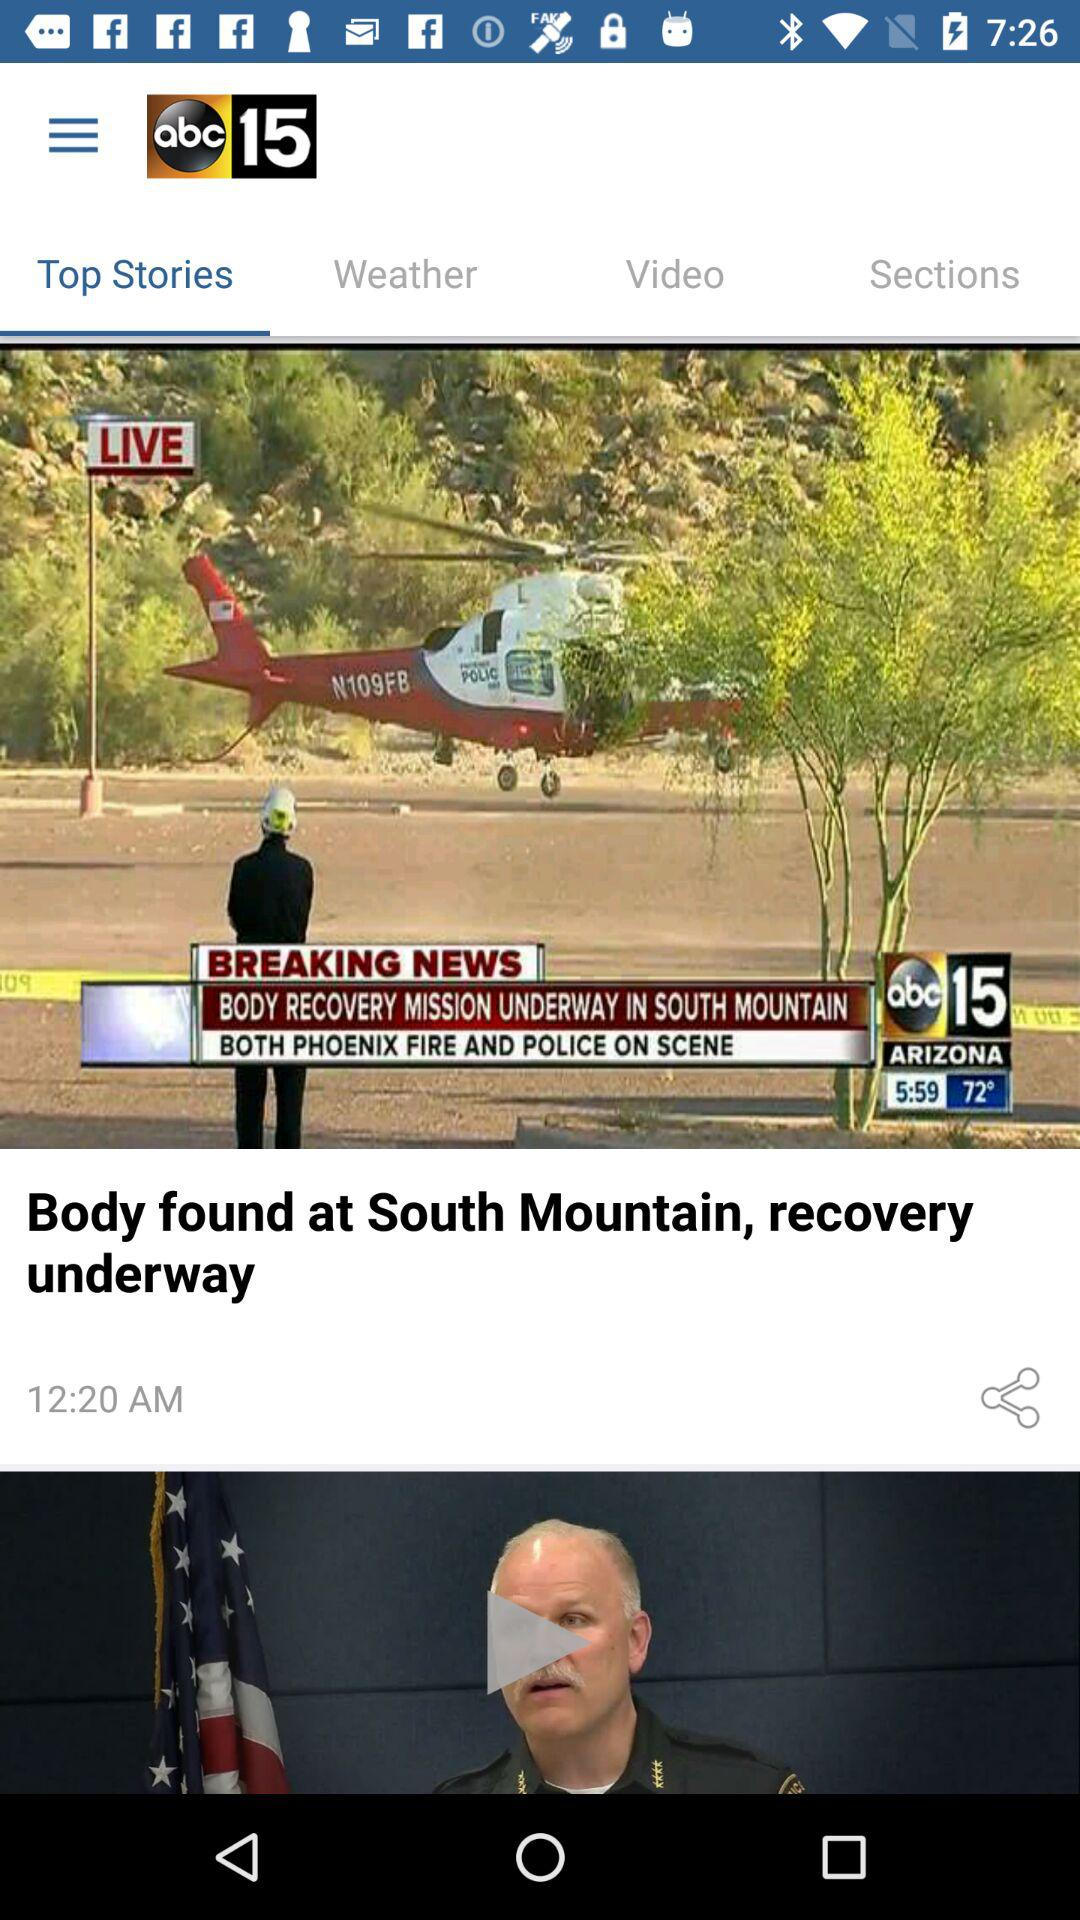What is the date of the news story?
When the provided information is insufficient, respond with <no answer>. <no answer> 